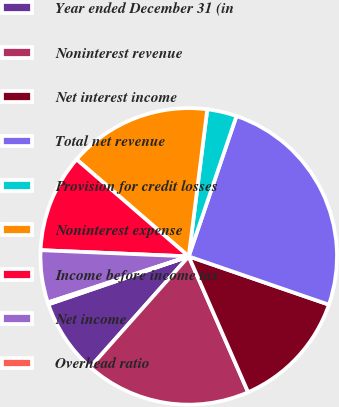Convert chart to OTSL. <chart><loc_0><loc_0><loc_500><loc_500><pie_chart><fcel>Year ended December 31 (in<fcel>Noninterest revenue<fcel>Net interest income<fcel>Total net revenue<fcel>Provision for credit losses<fcel>Noninterest expense<fcel>Income before income tax<fcel>Net income<fcel>Overhead ratio<nl><fcel>8.19%<fcel>18.13%<fcel>13.16%<fcel>25.06%<fcel>3.22%<fcel>15.65%<fcel>10.68%<fcel>5.7%<fcel>0.21%<nl></chart> 